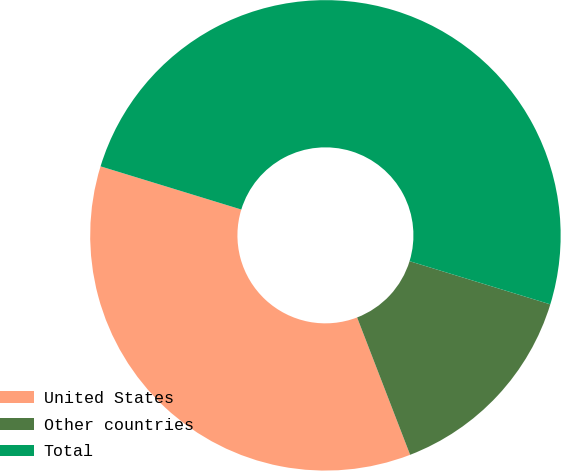Convert chart. <chart><loc_0><loc_0><loc_500><loc_500><pie_chart><fcel>United States<fcel>Other countries<fcel>Total<nl><fcel>35.6%<fcel>14.4%<fcel>50.0%<nl></chart> 